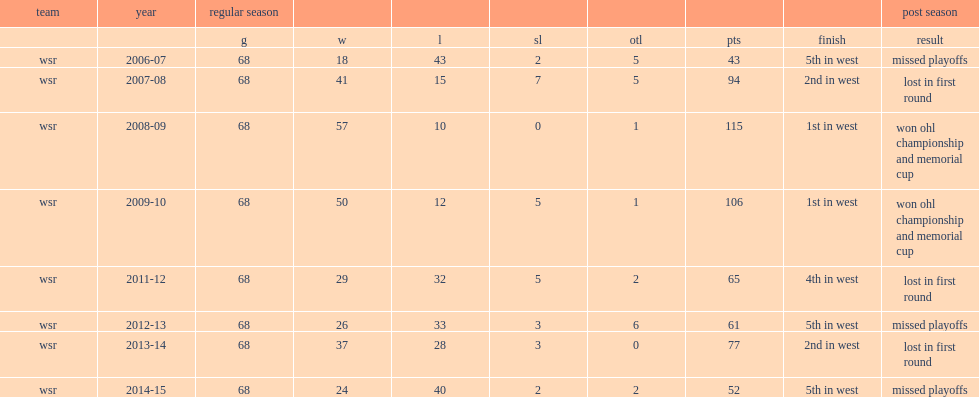What was the number of points in the regular season in 2009? 115.0. Parse the table in full. {'header': ['team', 'year', 'regular season', '', '', '', '', '', '', 'post season'], 'rows': [['', '', 'g', 'w', 'l', 'sl', 'otl', 'pts', 'finish', 'result'], ['wsr', '2006-07', '68', '18', '43', '2', '5', '43', '5th in west', 'missed playoffs'], ['wsr', '2007-08', '68', '41', '15', '7', '5', '94', '2nd in west', 'lost in first round'], ['wsr', '2008-09', '68', '57', '10', '0', '1', '115', '1st in west', 'won ohl championship and memorial cup'], ['wsr', '2009-10', '68', '50', '12', '5', '1', '106', '1st in west', 'won ohl championship and memorial cup'], ['wsr', '2011-12', '68', '29', '32', '5', '2', '65', '4th in west', 'lost in first round'], ['wsr', '2012-13', '68', '26', '33', '3', '6', '61', '5th in west', 'missed playoffs'], ['wsr', '2013-14', '68', '37', '28', '3', '0', '77', '2nd in west', 'lost in first round'], ['wsr', '2014-15', '68', '24', '40', '2', '2', '52', '5th in west', 'missed playoffs']]} 